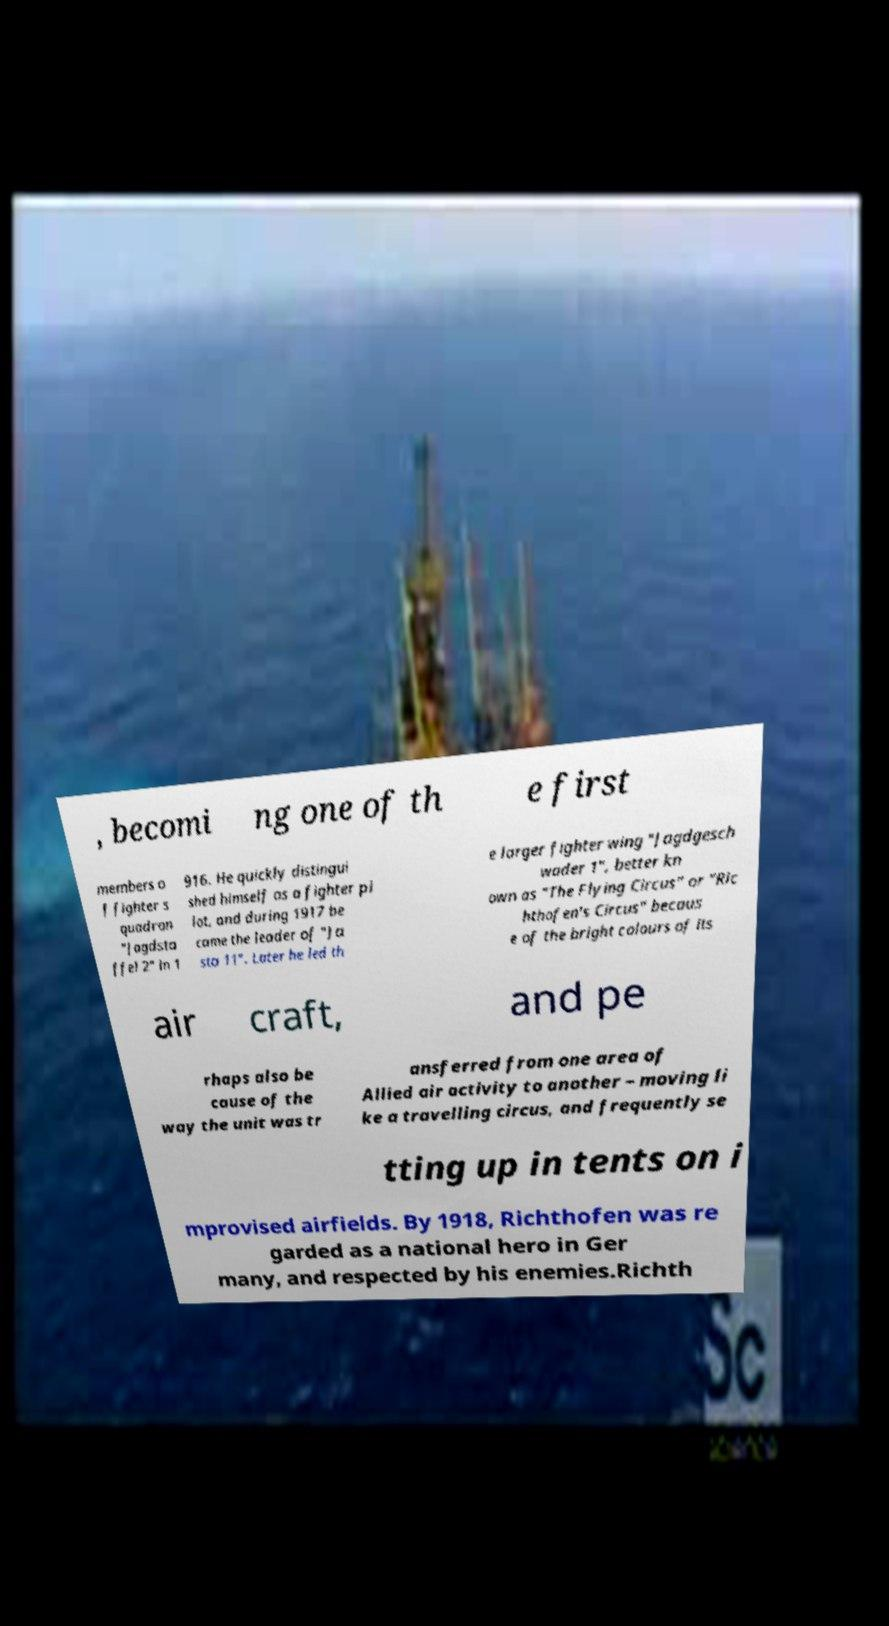I need the written content from this picture converted into text. Can you do that? , becomi ng one of th e first members o f fighter s quadron "Jagdsta ffel 2" in 1 916. He quickly distingui shed himself as a fighter pi lot, and during 1917 be came the leader of "Ja sta 11". Later he led th e larger fighter wing "Jagdgesch wader 1", better kn own as "The Flying Circus" or "Ric hthofen's Circus" becaus e of the bright colours of its air craft, and pe rhaps also be cause of the way the unit was tr ansferred from one area of Allied air activity to another – moving li ke a travelling circus, and frequently se tting up in tents on i mprovised airfields. By 1918, Richthofen was re garded as a national hero in Ger many, and respected by his enemies.Richth 